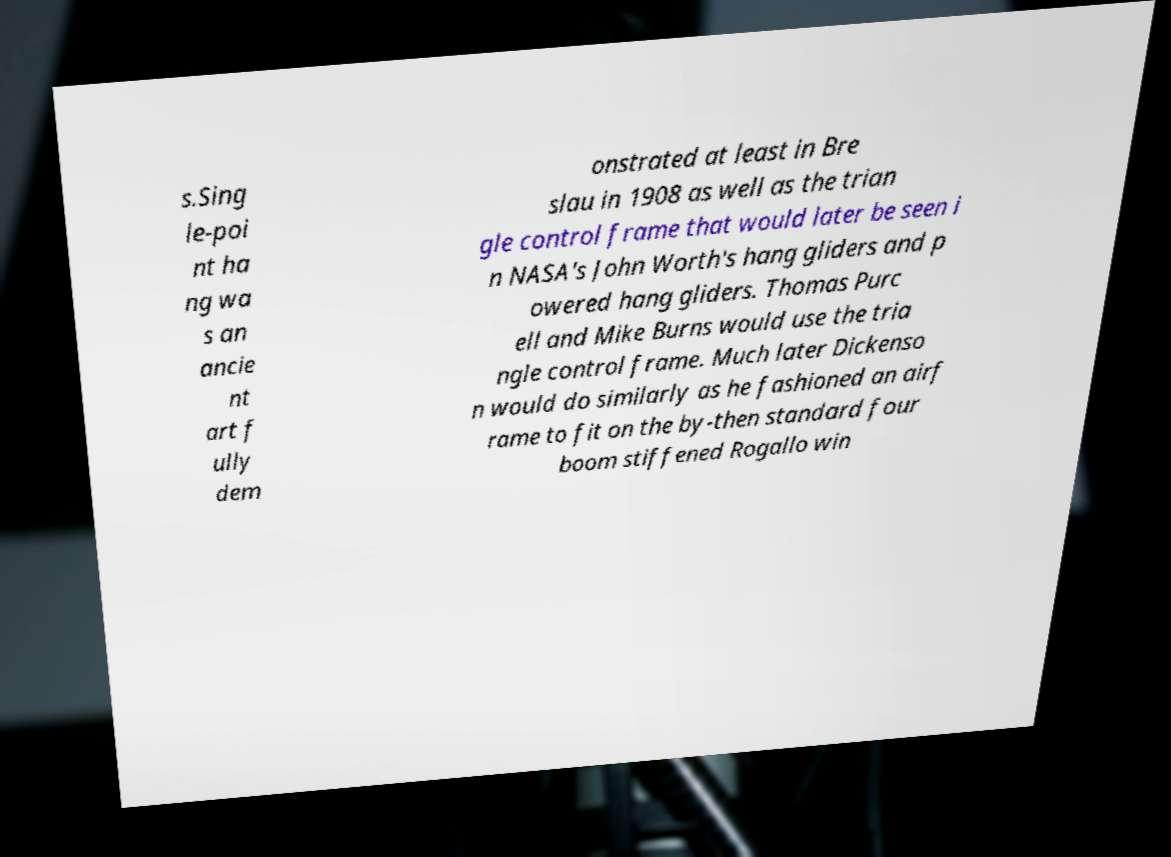Can you read and provide the text displayed in the image?This photo seems to have some interesting text. Can you extract and type it out for me? s.Sing le-poi nt ha ng wa s an ancie nt art f ully dem onstrated at least in Bre slau in 1908 as well as the trian gle control frame that would later be seen i n NASA's John Worth's hang gliders and p owered hang gliders. Thomas Purc ell and Mike Burns would use the tria ngle control frame. Much later Dickenso n would do similarly as he fashioned an airf rame to fit on the by-then standard four boom stiffened Rogallo win 